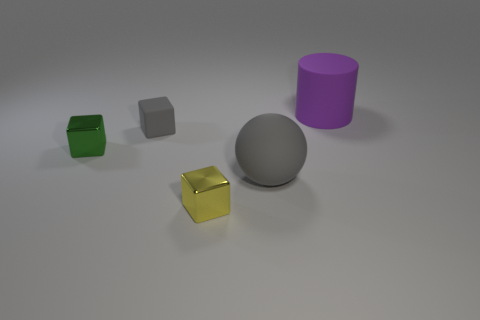There is a rubber ball that is the same color as the small matte thing; what size is it?
Offer a terse response. Large. Are there an equal number of small green things that are in front of the small green metal thing and balls that are on the left side of the tiny yellow shiny block?
Offer a terse response. Yes. There is a object that is both behind the green block and on the left side of the large purple matte thing; what is its shape?
Ensure brevity in your answer.  Cube. There is a rubber cube; what number of large gray things are in front of it?
Provide a succinct answer. 1. How many other things are there of the same shape as the tiny gray thing?
Your response must be concise. 2. Is the number of cubes less than the number of things?
Offer a terse response. Yes. What is the size of the rubber thing that is both right of the small yellow shiny cube and in front of the large cylinder?
Make the answer very short. Large. How big is the rubber thing in front of the tiny metallic object behind the small thing that is in front of the big gray matte object?
Provide a short and direct response. Large. What is the size of the sphere?
Offer a very short reply. Large. There is a tiny metal block that is behind the tiny shiny object that is on the right side of the small green block; is there a purple rubber cylinder in front of it?
Your answer should be very brief. No. 